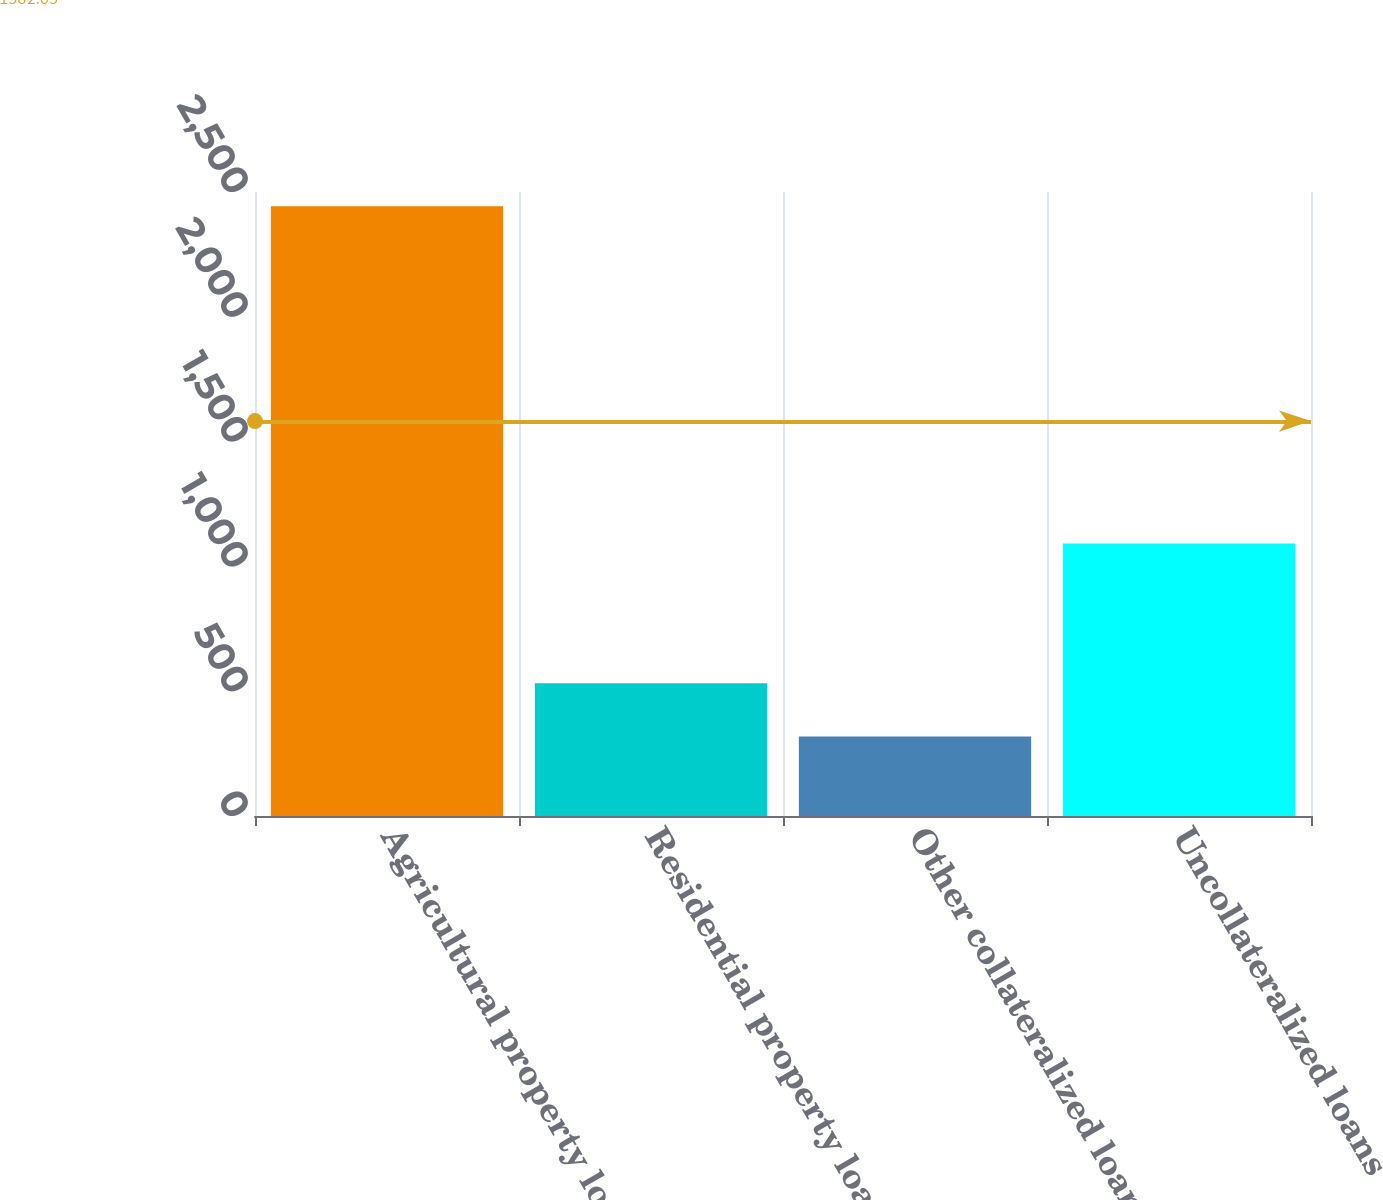Convert chart. <chart><loc_0><loc_0><loc_500><loc_500><bar_chart><fcel>Agricultural property loans<fcel>Residential property loans<fcel>Other collateralized loans<fcel>Uncollateralized loans<nl><fcel>2443<fcel>531.4<fcel>319<fcel>1092<nl></chart> 